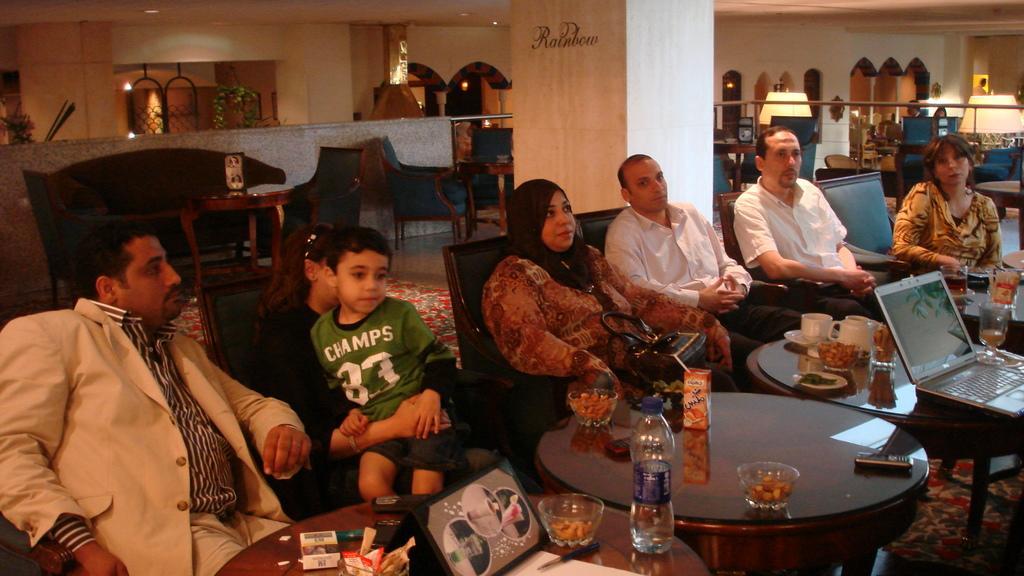Could you give a brief overview of what you see in this image? This image is taken inside a room. There are seven people in this room, three men and three women and a kid. At the bottom of the image there is a table and there were many things on it. At the background there is a wall, windows, plants and pillar. In this image there were many things. In the right side of the image there is a laptop on a table. 